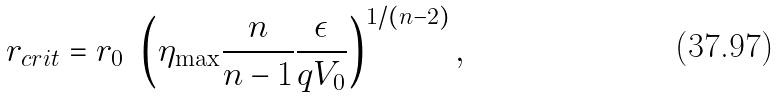Convert formula to latex. <formula><loc_0><loc_0><loc_500><loc_500>r _ { c r i t } = r _ { 0 } \ \left ( \eta _ { \max } \frac { n } { n - 1 } \frac { \epsilon } { q V _ { 0 } } \right ) ^ { 1 / ( n - 2 ) } ,</formula> 